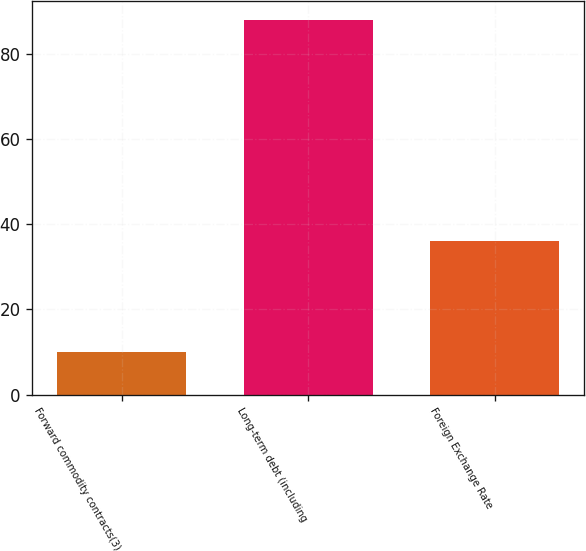Convert chart. <chart><loc_0><loc_0><loc_500><loc_500><bar_chart><fcel>Forward commodity contracts(3)<fcel>Long-term debt (including<fcel>Foreign Exchange Rate<nl><fcel>10<fcel>88<fcel>36<nl></chart> 